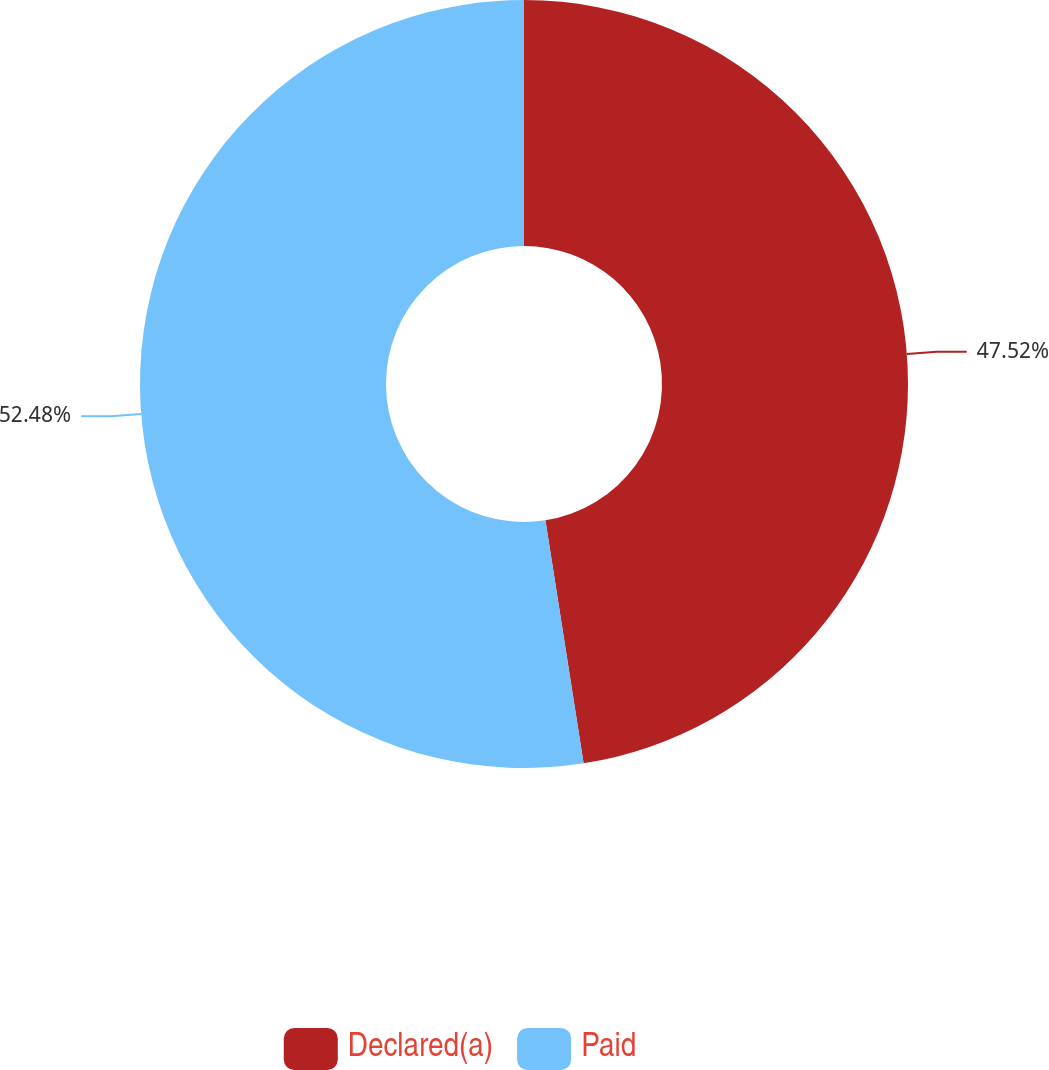Convert chart to OTSL. <chart><loc_0><loc_0><loc_500><loc_500><pie_chart><fcel>Declared(a)<fcel>Paid<nl><fcel>47.52%<fcel>52.48%<nl></chart> 